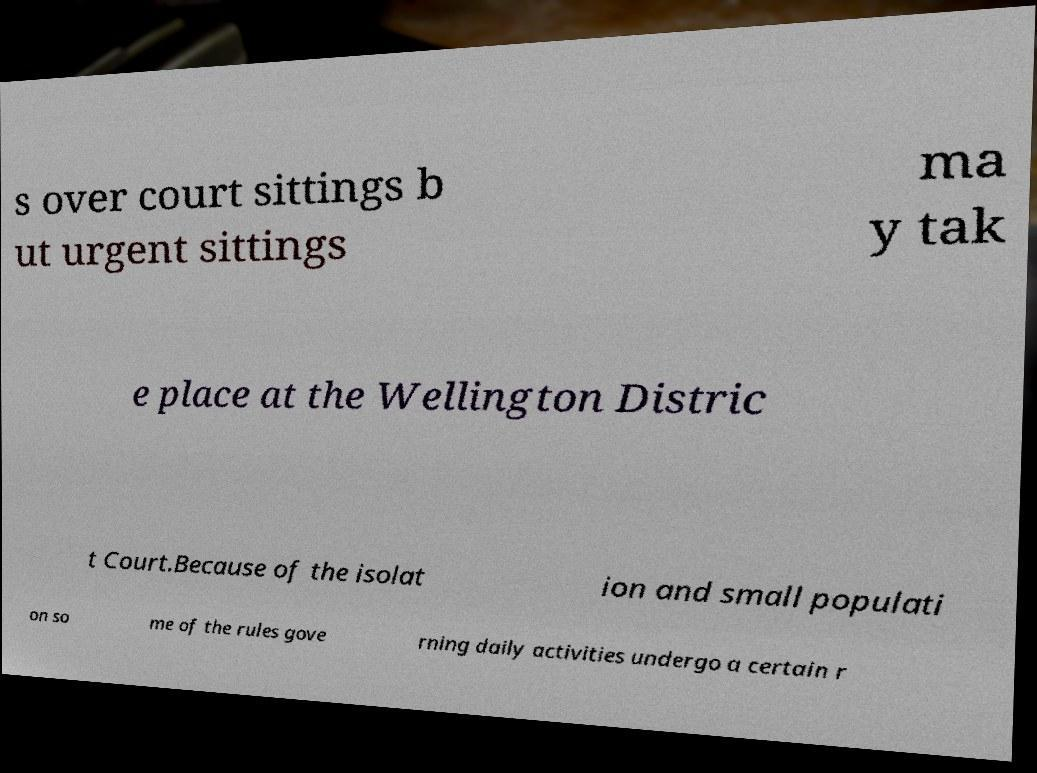Can you accurately transcribe the text from the provided image for me? s over court sittings b ut urgent sittings ma y tak e place at the Wellington Distric t Court.Because of the isolat ion and small populati on so me of the rules gove rning daily activities undergo a certain r 